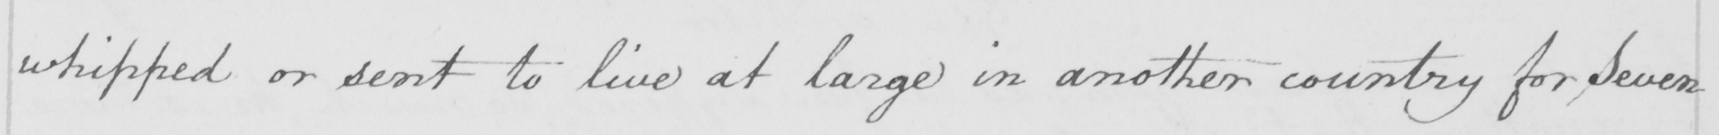What is written in this line of handwriting? whipped or sent to live at large in another country for , Seven 